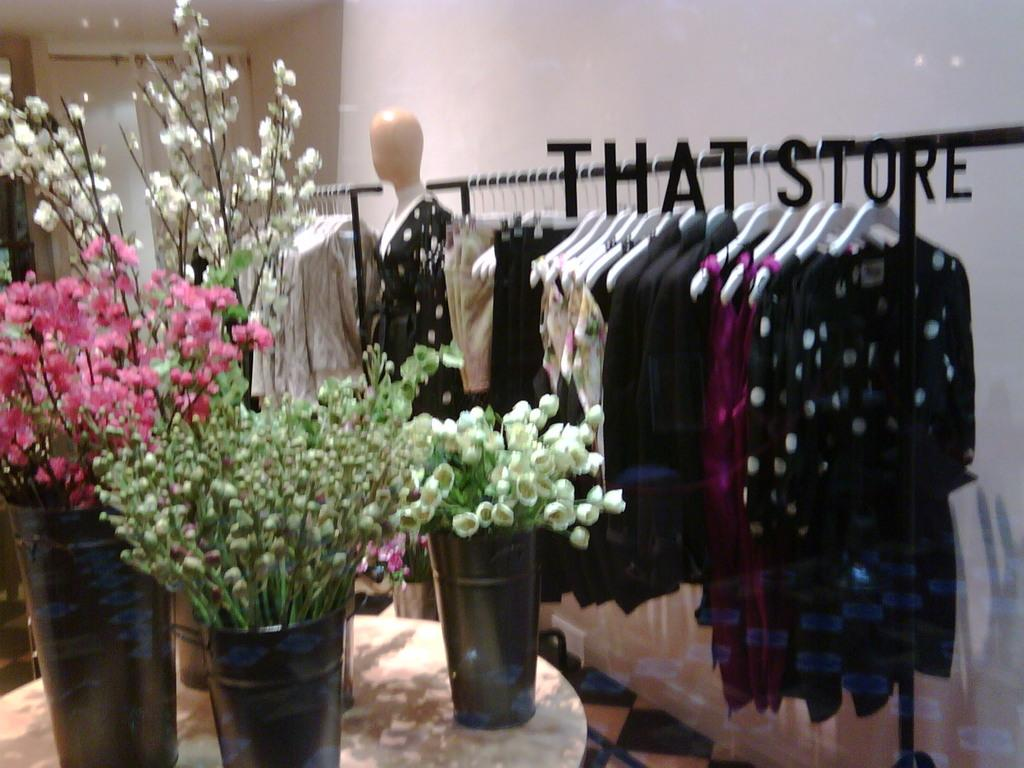What type of store is shown in the image? There is a clothing store in the image. What items are displayed in the store? Many dresses are hanged for display in the store. Can you describe any furniture or fixtures in the image? There is a white table in the image. What is placed on the table? Four flower pots are present on the table. How are the flower pots different from each other? Each flower pot contains a different type of flower. Is there a soda machine visible in the image? No, there is no soda machine present in the image. Does the existence of the clothing store prove the existence of a laborer in the image? The presence of a clothing store does not necessarily imply the existence of a laborer in the image. 